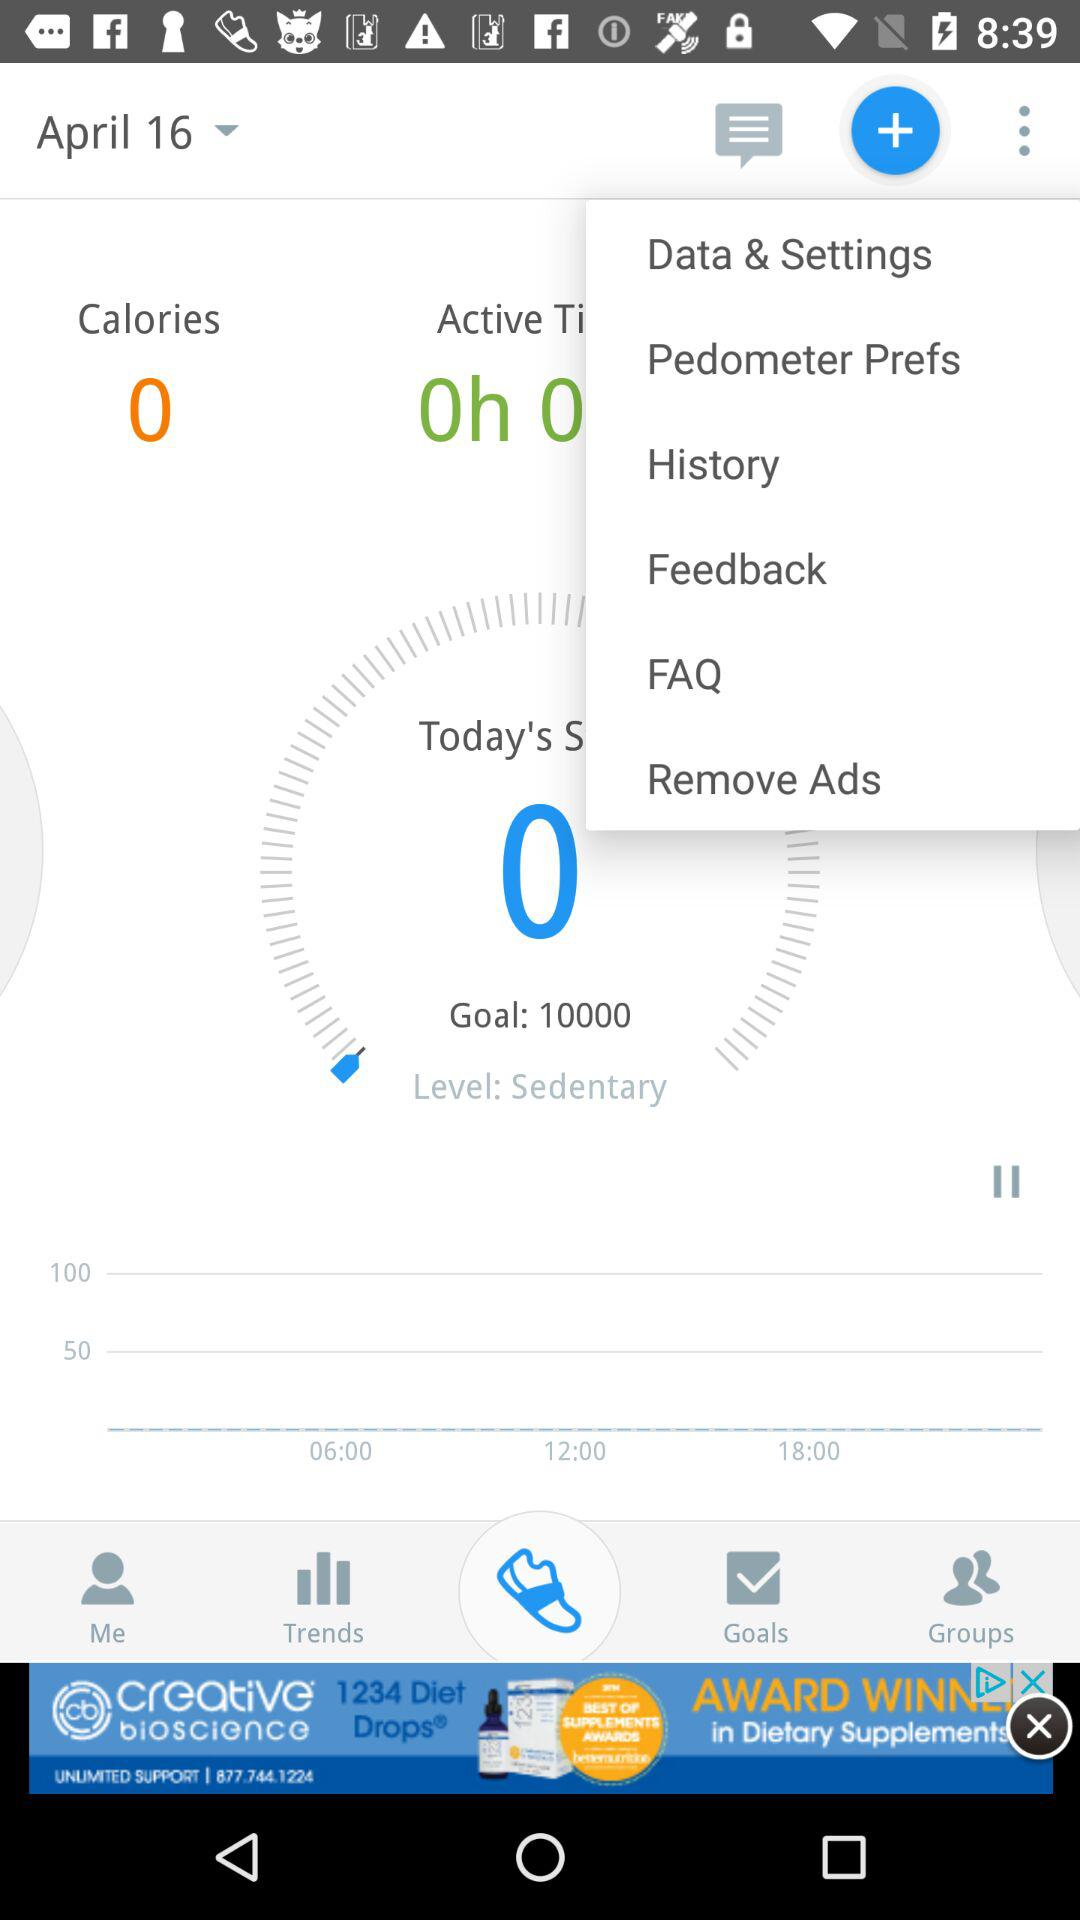What is the level? The level is sedentary. 